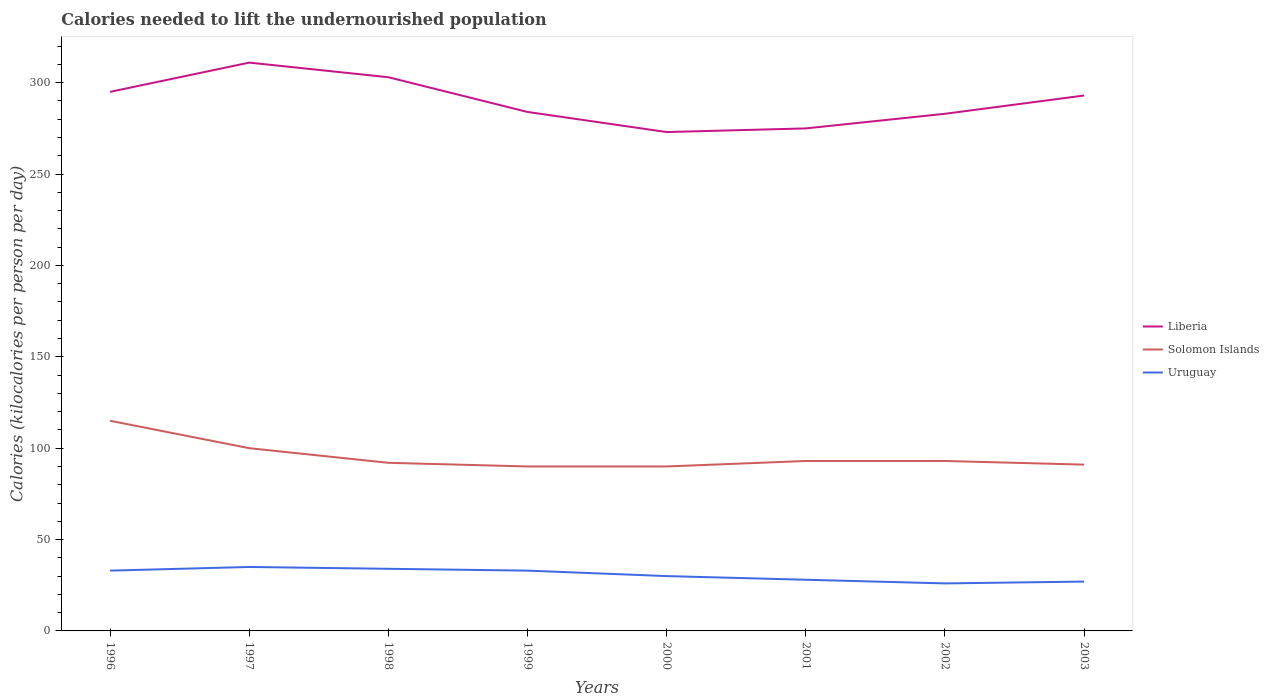How many different coloured lines are there?
Provide a succinct answer. 3. Across all years, what is the maximum total calories needed to lift the undernourished population in Uruguay?
Your answer should be compact. 26. What is the total total calories needed to lift the undernourished population in Liberia in the graph?
Your answer should be compact. 28. What is the difference between the highest and the second highest total calories needed to lift the undernourished population in Uruguay?
Offer a very short reply. 9. What is the difference between the highest and the lowest total calories needed to lift the undernourished population in Liberia?
Provide a short and direct response. 4. Is the total calories needed to lift the undernourished population in Uruguay strictly greater than the total calories needed to lift the undernourished population in Solomon Islands over the years?
Provide a succinct answer. Yes. How many years are there in the graph?
Offer a terse response. 8. What is the difference between two consecutive major ticks on the Y-axis?
Offer a terse response. 50. Are the values on the major ticks of Y-axis written in scientific E-notation?
Your response must be concise. No. Does the graph contain any zero values?
Provide a short and direct response. No. Does the graph contain grids?
Keep it short and to the point. No. Where does the legend appear in the graph?
Make the answer very short. Center right. How are the legend labels stacked?
Give a very brief answer. Vertical. What is the title of the graph?
Provide a short and direct response. Calories needed to lift the undernourished population. What is the label or title of the Y-axis?
Keep it short and to the point. Calories (kilocalories per person per day). What is the Calories (kilocalories per person per day) of Liberia in 1996?
Make the answer very short. 295. What is the Calories (kilocalories per person per day) in Solomon Islands in 1996?
Offer a terse response. 115. What is the Calories (kilocalories per person per day) in Uruguay in 1996?
Your answer should be very brief. 33. What is the Calories (kilocalories per person per day) of Liberia in 1997?
Offer a terse response. 311. What is the Calories (kilocalories per person per day) of Liberia in 1998?
Make the answer very short. 303. What is the Calories (kilocalories per person per day) of Solomon Islands in 1998?
Give a very brief answer. 92. What is the Calories (kilocalories per person per day) in Liberia in 1999?
Give a very brief answer. 284. What is the Calories (kilocalories per person per day) in Solomon Islands in 1999?
Keep it short and to the point. 90. What is the Calories (kilocalories per person per day) of Liberia in 2000?
Offer a terse response. 273. What is the Calories (kilocalories per person per day) in Solomon Islands in 2000?
Provide a short and direct response. 90. What is the Calories (kilocalories per person per day) in Uruguay in 2000?
Give a very brief answer. 30. What is the Calories (kilocalories per person per day) in Liberia in 2001?
Your response must be concise. 275. What is the Calories (kilocalories per person per day) of Solomon Islands in 2001?
Your answer should be very brief. 93. What is the Calories (kilocalories per person per day) of Liberia in 2002?
Offer a terse response. 283. What is the Calories (kilocalories per person per day) of Solomon Islands in 2002?
Offer a very short reply. 93. What is the Calories (kilocalories per person per day) of Liberia in 2003?
Your answer should be very brief. 293. What is the Calories (kilocalories per person per day) of Solomon Islands in 2003?
Provide a short and direct response. 91. What is the Calories (kilocalories per person per day) in Uruguay in 2003?
Provide a succinct answer. 27. Across all years, what is the maximum Calories (kilocalories per person per day) of Liberia?
Make the answer very short. 311. Across all years, what is the maximum Calories (kilocalories per person per day) of Solomon Islands?
Make the answer very short. 115. Across all years, what is the maximum Calories (kilocalories per person per day) of Uruguay?
Ensure brevity in your answer.  35. Across all years, what is the minimum Calories (kilocalories per person per day) of Liberia?
Your response must be concise. 273. Across all years, what is the minimum Calories (kilocalories per person per day) in Solomon Islands?
Provide a short and direct response. 90. Across all years, what is the minimum Calories (kilocalories per person per day) in Uruguay?
Give a very brief answer. 26. What is the total Calories (kilocalories per person per day) in Liberia in the graph?
Make the answer very short. 2317. What is the total Calories (kilocalories per person per day) of Solomon Islands in the graph?
Offer a very short reply. 764. What is the total Calories (kilocalories per person per day) in Uruguay in the graph?
Provide a succinct answer. 246. What is the difference between the Calories (kilocalories per person per day) of Liberia in 1996 and that in 1997?
Your answer should be very brief. -16. What is the difference between the Calories (kilocalories per person per day) of Solomon Islands in 1996 and that in 1997?
Your answer should be compact. 15. What is the difference between the Calories (kilocalories per person per day) of Solomon Islands in 1996 and that in 1999?
Give a very brief answer. 25. What is the difference between the Calories (kilocalories per person per day) of Uruguay in 1996 and that in 1999?
Your answer should be compact. 0. What is the difference between the Calories (kilocalories per person per day) in Uruguay in 1996 and that in 2000?
Keep it short and to the point. 3. What is the difference between the Calories (kilocalories per person per day) in Liberia in 1996 and that in 2002?
Your answer should be very brief. 12. What is the difference between the Calories (kilocalories per person per day) in Uruguay in 1996 and that in 2002?
Your answer should be very brief. 7. What is the difference between the Calories (kilocalories per person per day) of Liberia in 1996 and that in 2003?
Provide a succinct answer. 2. What is the difference between the Calories (kilocalories per person per day) of Solomon Islands in 1996 and that in 2003?
Make the answer very short. 24. What is the difference between the Calories (kilocalories per person per day) of Uruguay in 1996 and that in 2003?
Give a very brief answer. 6. What is the difference between the Calories (kilocalories per person per day) in Uruguay in 1997 and that in 1998?
Provide a succinct answer. 1. What is the difference between the Calories (kilocalories per person per day) of Liberia in 1997 and that in 1999?
Offer a very short reply. 27. What is the difference between the Calories (kilocalories per person per day) in Uruguay in 1997 and that in 2000?
Give a very brief answer. 5. What is the difference between the Calories (kilocalories per person per day) of Solomon Islands in 1997 and that in 2002?
Give a very brief answer. 7. What is the difference between the Calories (kilocalories per person per day) in Uruguay in 1997 and that in 2002?
Offer a terse response. 9. What is the difference between the Calories (kilocalories per person per day) of Solomon Islands in 1998 and that in 1999?
Offer a terse response. 2. What is the difference between the Calories (kilocalories per person per day) in Solomon Islands in 1998 and that in 2000?
Make the answer very short. 2. What is the difference between the Calories (kilocalories per person per day) of Uruguay in 1998 and that in 2000?
Offer a terse response. 4. What is the difference between the Calories (kilocalories per person per day) of Solomon Islands in 1998 and that in 2001?
Your answer should be very brief. -1. What is the difference between the Calories (kilocalories per person per day) in Uruguay in 1998 and that in 2001?
Your answer should be compact. 6. What is the difference between the Calories (kilocalories per person per day) in Liberia in 1998 and that in 2002?
Offer a terse response. 20. What is the difference between the Calories (kilocalories per person per day) in Solomon Islands in 1998 and that in 2002?
Keep it short and to the point. -1. What is the difference between the Calories (kilocalories per person per day) of Uruguay in 1998 and that in 2002?
Provide a short and direct response. 8. What is the difference between the Calories (kilocalories per person per day) in Liberia in 1998 and that in 2003?
Make the answer very short. 10. What is the difference between the Calories (kilocalories per person per day) of Liberia in 1999 and that in 2000?
Your response must be concise. 11. What is the difference between the Calories (kilocalories per person per day) of Solomon Islands in 1999 and that in 2000?
Your answer should be very brief. 0. What is the difference between the Calories (kilocalories per person per day) in Solomon Islands in 1999 and that in 2001?
Make the answer very short. -3. What is the difference between the Calories (kilocalories per person per day) of Liberia in 1999 and that in 2002?
Provide a succinct answer. 1. What is the difference between the Calories (kilocalories per person per day) in Solomon Islands in 1999 and that in 2002?
Provide a short and direct response. -3. What is the difference between the Calories (kilocalories per person per day) of Uruguay in 1999 and that in 2002?
Give a very brief answer. 7. What is the difference between the Calories (kilocalories per person per day) of Liberia in 1999 and that in 2003?
Your response must be concise. -9. What is the difference between the Calories (kilocalories per person per day) in Solomon Islands in 1999 and that in 2003?
Your answer should be very brief. -1. What is the difference between the Calories (kilocalories per person per day) of Uruguay in 2000 and that in 2001?
Make the answer very short. 2. What is the difference between the Calories (kilocalories per person per day) in Solomon Islands in 2000 and that in 2002?
Provide a short and direct response. -3. What is the difference between the Calories (kilocalories per person per day) of Uruguay in 2000 and that in 2002?
Provide a succinct answer. 4. What is the difference between the Calories (kilocalories per person per day) of Liberia in 2000 and that in 2003?
Make the answer very short. -20. What is the difference between the Calories (kilocalories per person per day) in Solomon Islands in 2000 and that in 2003?
Ensure brevity in your answer.  -1. What is the difference between the Calories (kilocalories per person per day) of Solomon Islands in 2001 and that in 2002?
Keep it short and to the point. 0. What is the difference between the Calories (kilocalories per person per day) of Uruguay in 2001 and that in 2002?
Give a very brief answer. 2. What is the difference between the Calories (kilocalories per person per day) in Solomon Islands in 2001 and that in 2003?
Keep it short and to the point. 2. What is the difference between the Calories (kilocalories per person per day) in Liberia in 2002 and that in 2003?
Your answer should be very brief. -10. What is the difference between the Calories (kilocalories per person per day) in Uruguay in 2002 and that in 2003?
Provide a short and direct response. -1. What is the difference between the Calories (kilocalories per person per day) of Liberia in 1996 and the Calories (kilocalories per person per day) of Solomon Islands in 1997?
Your response must be concise. 195. What is the difference between the Calories (kilocalories per person per day) of Liberia in 1996 and the Calories (kilocalories per person per day) of Uruguay in 1997?
Your answer should be compact. 260. What is the difference between the Calories (kilocalories per person per day) in Liberia in 1996 and the Calories (kilocalories per person per day) in Solomon Islands in 1998?
Keep it short and to the point. 203. What is the difference between the Calories (kilocalories per person per day) of Liberia in 1996 and the Calories (kilocalories per person per day) of Uruguay in 1998?
Your answer should be very brief. 261. What is the difference between the Calories (kilocalories per person per day) of Liberia in 1996 and the Calories (kilocalories per person per day) of Solomon Islands in 1999?
Provide a short and direct response. 205. What is the difference between the Calories (kilocalories per person per day) of Liberia in 1996 and the Calories (kilocalories per person per day) of Uruguay in 1999?
Your response must be concise. 262. What is the difference between the Calories (kilocalories per person per day) in Solomon Islands in 1996 and the Calories (kilocalories per person per day) in Uruguay in 1999?
Your response must be concise. 82. What is the difference between the Calories (kilocalories per person per day) in Liberia in 1996 and the Calories (kilocalories per person per day) in Solomon Islands in 2000?
Offer a very short reply. 205. What is the difference between the Calories (kilocalories per person per day) in Liberia in 1996 and the Calories (kilocalories per person per day) in Uruguay in 2000?
Make the answer very short. 265. What is the difference between the Calories (kilocalories per person per day) in Liberia in 1996 and the Calories (kilocalories per person per day) in Solomon Islands in 2001?
Provide a succinct answer. 202. What is the difference between the Calories (kilocalories per person per day) of Liberia in 1996 and the Calories (kilocalories per person per day) of Uruguay in 2001?
Offer a very short reply. 267. What is the difference between the Calories (kilocalories per person per day) in Solomon Islands in 1996 and the Calories (kilocalories per person per day) in Uruguay in 2001?
Your response must be concise. 87. What is the difference between the Calories (kilocalories per person per day) in Liberia in 1996 and the Calories (kilocalories per person per day) in Solomon Islands in 2002?
Offer a terse response. 202. What is the difference between the Calories (kilocalories per person per day) in Liberia in 1996 and the Calories (kilocalories per person per day) in Uruguay in 2002?
Your response must be concise. 269. What is the difference between the Calories (kilocalories per person per day) of Solomon Islands in 1996 and the Calories (kilocalories per person per day) of Uruguay in 2002?
Provide a succinct answer. 89. What is the difference between the Calories (kilocalories per person per day) of Liberia in 1996 and the Calories (kilocalories per person per day) of Solomon Islands in 2003?
Provide a succinct answer. 204. What is the difference between the Calories (kilocalories per person per day) of Liberia in 1996 and the Calories (kilocalories per person per day) of Uruguay in 2003?
Your response must be concise. 268. What is the difference between the Calories (kilocalories per person per day) in Liberia in 1997 and the Calories (kilocalories per person per day) in Solomon Islands in 1998?
Keep it short and to the point. 219. What is the difference between the Calories (kilocalories per person per day) of Liberia in 1997 and the Calories (kilocalories per person per day) of Uruguay in 1998?
Your response must be concise. 277. What is the difference between the Calories (kilocalories per person per day) in Solomon Islands in 1997 and the Calories (kilocalories per person per day) in Uruguay in 1998?
Ensure brevity in your answer.  66. What is the difference between the Calories (kilocalories per person per day) in Liberia in 1997 and the Calories (kilocalories per person per day) in Solomon Islands in 1999?
Offer a terse response. 221. What is the difference between the Calories (kilocalories per person per day) of Liberia in 1997 and the Calories (kilocalories per person per day) of Uruguay in 1999?
Offer a very short reply. 278. What is the difference between the Calories (kilocalories per person per day) of Liberia in 1997 and the Calories (kilocalories per person per day) of Solomon Islands in 2000?
Make the answer very short. 221. What is the difference between the Calories (kilocalories per person per day) of Liberia in 1997 and the Calories (kilocalories per person per day) of Uruguay in 2000?
Give a very brief answer. 281. What is the difference between the Calories (kilocalories per person per day) in Solomon Islands in 1997 and the Calories (kilocalories per person per day) in Uruguay in 2000?
Give a very brief answer. 70. What is the difference between the Calories (kilocalories per person per day) of Liberia in 1997 and the Calories (kilocalories per person per day) of Solomon Islands in 2001?
Your response must be concise. 218. What is the difference between the Calories (kilocalories per person per day) in Liberia in 1997 and the Calories (kilocalories per person per day) in Uruguay in 2001?
Your answer should be very brief. 283. What is the difference between the Calories (kilocalories per person per day) in Liberia in 1997 and the Calories (kilocalories per person per day) in Solomon Islands in 2002?
Offer a terse response. 218. What is the difference between the Calories (kilocalories per person per day) in Liberia in 1997 and the Calories (kilocalories per person per day) in Uruguay in 2002?
Provide a short and direct response. 285. What is the difference between the Calories (kilocalories per person per day) in Solomon Islands in 1997 and the Calories (kilocalories per person per day) in Uruguay in 2002?
Your answer should be compact. 74. What is the difference between the Calories (kilocalories per person per day) in Liberia in 1997 and the Calories (kilocalories per person per day) in Solomon Islands in 2003?
Offer a terse response. 220. What is the difference between the Calories (kilocalories per person per day) in Liberia in 1997 and the Calories (kilocalories per person per day) in Uruguay in 2003?
Make the answer very short. 284. What is the difference between the Calories (kilocalories per person per day) in Liberia in 1998 and the Calories (kilocalories per person per day) in Solomon Islands in 1999?
Offer a terse response. 213. What is the difference between the Calories (kilocalories per person per day) of Liberia in 1998 and the Calories (kilocalories per person per day) of Uruguay in 1999?
Your answer should be very brief. 270. What is the difference between the Calories (kilocalories per person per day) in Solomon Islands in 1998 and the Calories (kilocalories per person per day) in Uruguay in 1999?
Your response must be concise. 59. What is the difference between the Calories (kilocalories per person per day) of Liberia in 1998 and the Calories (kilocalories per person per day) of Solomon Islands in 2000?
Your response must be concise. 213. What is the difference between the Calories (kilocalories per person per day) of Liberia in 1998 and the Calories (kilocalories per person per day) of Uruguay in 2000?
Keep it short and to the point. 273. What is the difference between the Calories (kilocalories per person per day) of Solomon Islands in 1998 and the Calories (kilocalories per person per day) of Uruguay in 2000?
Provide a succinct answer. 62. What is the difference between the Calories (kilocalories per person per day) in Liberia in 1998 and the Calories (kilocalories per person per day) in Solomon Islands in 2001?
Your answer should be compact. 210. What is the difference between the Calories (kilocalories per person per day) in Liberia in 1998 and the Calories (kilocalories per person per day) in Uruguay in 2001?
Offer a very short reply. 275. What is the difference between the Calories (kilocalories per person per day) in Solomon Islands in 1998 and the Calories (kilocalories per person per day) in Uruguay in 2001?
Give a very brief answer. 64. What is the difference between the Calories (kilocalories per person per day) in Liberia in 1998 and the Calories (kilocalories per person per day) in Solomon Islands in 2002?
Your answer should be very brief. 210. What is the difference between the Calories (kilocalories per person per day) in Liberia in 1998 and the Calories (kilocalories per person per day) in Uruguay in 2002?
Your response must be concise. 277. What is the difference between the Calories (kilocalories per person per day) in Liberia in 1998 and the Calories (kilocalories per person per day) in Solomon Islands in 2003?
Offer a terse response. 212. What is the difference between the Calories (kilocalories per person per day) of Liberia in 1998 and the Calories (kilocalories per person per day) of Uruguay in 2003?
Ensure brevity in your answer.  276. What is the difference between the Calories (kilocalories per person per day) in Liberia in 1999 and the Calories (kilocalories per person per day) in Solomon Islands in 2000?
Offer a terse response. 194. What is the difference between the Calories (kilocalories per person per day) of Liberia in 1999 and the Calories (kilocalories per person per day) of Uruguay in 2000?
Ensure brevity in your answer.  254. What is the difference between the Calories (kilocalories per person per day) of Liberia in 1999 and the Calories (kilocalories per person per day) of Solomon Islands in 2001?
Provide a short and direct response. 191. What is the difference between the Calories (kilocalories per person per day) of Liberia in 1999 and the Calories (kilocalories per person per day) of Uruguay in 2001?
Your answer should be compact. 256. What is the difference between the Calories (kilocalories per person per day) in Solomon Islands in 1999 and the Calories (kilocalories per person per day) in Uruguay in 2001?
Offer a very short reply. 62. What is the difference between the Calories (kilocalories per person per day) of Liberia in 1999 and the Calories (kilocalories per person per day) of Solomon Islands in 2002?
Give a very brief answer. 191. What is the difference between the Calories (kilocalories per person per day) of Liberia in 1999 and the Calories (kilocalories per person per day) of Uruguay in 2002?
Keep it short and to the point. 258. What is the difference between the Calories (kilocalories per person per day) in Liberia in 1999 and the Calories (kilocalories per person per day) in Solomon Islands in 2003?
Provide a short and direct response. 193. What is the difference between the Calories (kilocalories per person per day) of Liberia in 1999 and the Calories (kilocalories per person per day) of Uruguay in 2003?
Offer a terse response. 257. What is the difference between the Calories (kilocalories per person per day) in Solomon Islands in 1999 and the Calories (kilocalories per person per day) in Uruguay in 2003?
Offer a terse response. 63. What is the difference between the Calories (kilocalories per person per day) in Liberia in 2000 and the Calories (kilocalories per person per day) in Solomon Islands in 2001?
Your response must be concise. 180. What is the difference between the Calories (kilocalories per person per day) in Liberia in 2000 and the Calories (kilocalories per person per day) in Uruguay in 2001?
Keep it short and to the point. 245. What is the difference between the Calories (kilocalories per person per day) of Liberia in 2000 and the Calories (kilocalories per person per day) of Solomon Islands in 2002?
Your answer should be very brief. 180. What is the difference between the Calories (kilocalories per person per day) of Liberia in 2000 and the Calories (kilocalories per person per day) of Uruguay in 2002?
Keep it short and to the point. 247. What is the difference between the Calories (kilocalories per person per day) in Solomon Islands in 2000 and the Calories (kilocalories per person per day) in Uruguay in 2002?
Your response must be concise. 64. What is the difference between the Calories (kilocalories per person per day) in Liberia in 2000 and the Calories (kilocalories per person per day) in Solomon Islands in 2003?
Provide a succinct answer. 182. What is the difference between the Calories (kilocalories per person per day) of Liberia in 2000 and the Calories (kilocalories per person per day) of Uruguay in 2003?
Provide a short and direct response. 246. What is the difference between the Calories (kilocalories per person per day) of Solomon Islands in 2000 and the Calories (kilocalories per person per day) of Uruguay in 2003?
Provide a short and direct response. 63. What is the difference between the Calories (kilocalories per person per day) in Liberia in 2001 and the Calories (kilocalories per person per day) in Solomon Islands in 2002?
Give a very brief answer. 182. What is the difference between the Calories (kilocalories per person per day) in Liberia in 2001 and the Calories (kilocalories per person per day) in Uruguay in 2002?
Your answer should be compact. 249. What is the difference between the Calories (kilocalories per person per day) of Solomon Islands in 2001 and the Calories (kilocalories per person per day) of Uruguay in 2002?
Your response must be concise. 67. What is the difference between the Calories (kilocalories per person per day) in Liberia in 2001 and the Calories (kilocalories per person per day) in Solomon Islands in 2003?
Ensure brevity in your answer.  184. What is the difference between the Calories (kilocalories per person per day) in Liberia in 2001 and the Calories (kilocalories per person per day) in Uruguay in 2003?
Provide a short and direct response. 248. What is the difference between the Calories (kilocalories per person per day) of Solomon Islands in 2001 and the Calories (kilocalories per person per day) of Uruguay in 2003?
Your answer should be compact. 66. What is the difference between the Calories (kilocalories per person per day) of Liberia in 2002 and the Calories (kilocalories per person per day) of Solomon Islands in 2003?
Provide a succinct answer. 192. What is the difference between the Calories (kilocalories per person per day) of Liberia in 2002 and the Calories (kilocalories per person per day) of Uruguay in 2003?
Provide a short and direct response. 256. What is the average Calories (kilocalories per person per day) of Liberia per year?
Offer a very short reply. 289.62. What is the average Calories (kilocalories per person per day) of Solomon Islands per year?
Your response must be concise. 95.5. What is the average Calories (kilocalories per person per day) in Uruguay per year?
Your response must be concise. 30.75. In the year 1996, what is the difference between the Calories (kilocalories per person per day) in Liberia and Calories (kilocalories per person per day) in Solomon Islands?
Keep it short and to the point. 180. In the year 1996, what is the difference between the Calories (kilocalories per person per day) in Liberia and Calories (kilocalories per person per day) in Uruguay?
Give a very brief answer. 262. In the year 1996, what is the difference between the Calories (kilocalories per person per day) in Solomon Islands and Calories (kilocalories per person per day) in Uruguay?
Keep it short and to the point. 82. In the year 1997, what is the difference between the Calories (kilocalories per person per day) in Liberia and Calories (kilocalories per person per day) in Solomon Islands?
Offer a terse response. 211. In the year 1997, what is the difference between the Calories (kilocalories per person per day) of Liberia and Calories (kilocalories per person per day) of Uruguay?
Your answer should be compact. 276. In the year 1997, what is the difference between the Calories (kilocalories per person per day) in Solomon Islands and Calories (kilocalories per person per day) in Uruguay?
Offer a very short reply. 65. In the year 1998, what is the difference between the Calories (kilocalories per person per day) of Liberia and Calories (kilocalories per person per day) of Solomon Islands?
Make the answer very short. 211. In the year 1998, what is the difference between the Calories (kilocalories per person per day) of Liberia and Calories (kilocalories per person per day) of Uruguay?
Your answer should be very brief. 269. In the year 1998, what is the difference between the Calories (kilocalories per person per day) in Solomon Islands and Calories (kilocalories per person per day) in Uruguay?
Provide a succinct answer. 58. In the year 1999, what is the difference between the Calories (kilocalories per person per day) of Liberia and Calories (kilocalories per person per day) of Solomon Islands?
Provide a short and direct response. 194. In the year 1999, what is the difference between the Calories (kilocalories per person per day) in Liberia and Calories (kilocalories per person per day) in Uruguay?
Ensure brevity in your answer.  251. In the year 1999, what is the difference between the Calories (kilocalories per person per day) of Solomon Islands and Calories (kilocalories per person per day) of Uruguay?
Give a very brief answer. 57. In the year 2000, what is the difference between the Calories (kilocalories per person per day) in Liberia and Calories (kilocalories per person per day) in Solomon Islands?
Offer a terse response. 183. In the year 2000, what is the difference between the Calories (kilocalories per person per day) in Liberia and Calories (kilocalories per person per day) in Uruguay?
Make the answer very short. 243. In the year 2000, what is the difference between the Calories (kilocalories per person per day) in Solomon Islands and Calories (kilocalories per person per day) in Uruguay?
Offer a very short reply. 60. In the year 2001, what is the difference between the Calories (kilocalories per person per day) in Liberia and Calories (kilocalories per person per day) in Solomon Islands?
Your answer should be compact. 182. In the year 2001, what is the difference between the Calories (kilocalories per person per day) in Liberia and Calories (kilocalories per person per day) in Uruguay?
Offer a very short reply. 247. In the year 2002, what is the difference between the Calories (kilocalories per person per day) in Liberia and Calories (kilocalories per person per day) in Solomon Islands?
Offer a terse response. 190. In the year 2002, what is the difference between the Calories (kilocalories per person per day) in Liberia and Calories (kilocalories per person per day) in Uruguay?
Keep it short and to the point. 257. In the year 2003, what is the difference between the Calories (kilocalories per person per day) in Liberia and Calories (kilocalories per person per day) in Solomon Islands?
Offer a terse response. 202. In the year 2003, what is the difference between the Calories (kilocalories per person per day) of Liberia and Calories (kilocalories per person per day) of Uruguay?
Provide a short and direct response. 266. In the year 2003, what is the difference between the Calories (kilocalories per person per day) in Solomon Islands and Calories (kilocalories per person per day) in Uruguay?
Your answer should be very brief. 64. What is the ratio of the Calories (kilocalories per person per day) in Liberia in 1996 to that in 1997?
Give a very brief answer. 0.95. What is the ratio of the Calories (kilocalories per person per day) in Solomon Islands in 1996 to that in 1997?
Give a very brief answer. 1.15. What is the ratio of the Calories (kilocalories per person per day) of Uruguay in 1996 to that in 1997?
Provide a short and direct response. 0.94. What is the ratio of the Calories (kilocalories per person per day) of Liberia in 1996 to that in 1998?
Make the answer very short. 0.97. What is the ratio of the Calories (kilocalories per person per day) of Uruguay in 1996 to that in 1998?
Offer a very short reply. 0.97. What is the ratio of the Calories (kilocalories per person per day) of Liberia in 1996 to that in 1999?
Keep it short and to the point. 1.04. What is the ratio of the Calories (kilocalories per person per day) of Solomon Islands in 1996 to that in 1999?
Offer a very short reply. 1.28. What is the ratio of the Calories (kilocalories per person per day) in Liberia in 1996 to that in 2000?
Keep it short and to the point. 1.08. What is the ratio of the Calories (kilocalories per person per day) of Solomon Islands in 1996 to that in 2000?
Your response must be concise. 1.28. What is the ratio of the Calories (kilocalories per person per day) of Liberia in 1996 to that in 2001?
Give a very brief answer. 1.07. What is the ratio of the Calories (kilocalories per person per day) in Solomon Islands in 1996 to that in 2001?
Ensure brevity in your answer.  1.24. What is the ratio of the Calories (kilocalories per person per day) in Uruguay in 1996 to that in 2001?
Provide a succinct answer. 1.18. What is the ratio of the Calories (kilocalories per person per day) of Liberia in 1996 to that in 2002?
Ensure brevity in your answer.  1.04. What is the ratio of the Calories (kilocalories per person per day) in Solomon Islands in 1996 to that in 2002?
Offer a terse response. 1.24. What is the ratio of the Calories (kilocalories per person per day) of Uruguay in 1996 to that in 2002?
Provide a succinct answer. 1.27. What is the ratio of the Calories (kilocalories per person per day) in Liberia in 1996 to that in 2003?
Provide a succinct answer. 1.01. What is the ratio of the Calories (kilocalories per person per day) in Solomon Islands in 1996 to that in 2003?
Offer a terse response. 1.26. What is the ratio of the Calories (kilocalories per person per day) of Uruguay in 1996 to that in 2003?
Keep it short and to the point. 1.22. What is the ratio of the Calories (kilocalories per person per day) of Liberia in 1997 to that in 1998?
Provide a short and direct response. 1.03. What is the ratio of the Calories (kilocalories per person per day) of Solomon Islands in 1997 to that in 1998?
Ensure brevity in your answer.  1.09. What is the ratio of the Calories (kilocalories per person per day) of Uruguay in 1997 to that in 1998?
Your answer should be compact. 1.03. What is the ratio of the Calories (kilocalories per person per day) in Liberia in 1997 to that in 1999?
Provide a succinct answer. 1.1. What is the ratio of the Calories (kilocalories per person per day) in Uruguay in 1997 to that in 1999?
Provide a short and direct response. 1.06. What is the ratio of the Calories (kilocalories per person per day) of Liberia in 1997 to that in 2000?
Offer a terse response. 1.14. What is the ratio of the Calories (kilocalories per person per day) in Solomon Islands in 1997 to that in 2000?
Provide a succinct answer. 1.11. What is the ratio of the Calories (kilocalories per person per day) in Liberia in 1997 to that in 2001?
Your answer should be compact. 1.13. What is the ratio of the Calories (kilocalories per person per day) of Solomon Islands in 1997 to that in 2001?
Give a very brief answer. 1.08. What is the ratio of the Calories (kilocalories per person per day) in Uruguay in 1997 to that in 2001?
Make the answer very short. 1.25. What is the ratio of the Calories (kilocalories per person per day) in Liberia in 1997 to that in 2002?
Make the answer very short. 1.1. What is the ratio of the Calories (kilocalories per person per day) of Solomon Islands in 1997 to that in 2002?
Keep it short and to the point. 1.08. What is the ratio of the Calories (kilocalories per person per day) of Uruguay in 1997 to that in 2002?
Your answer should be very brief. 1.35. What is the ratio of the Calories (kilocalories per person per day) of Liberia in 1997 to that in 2003?
Provide a short and direct response. 1.06. What is the ratio of the Calories (kilocalories per person per day) in Solomon Islands in 1997 to that in 2003?
Your answer should be compact. 1.1. What is the ratio of the Calories (kilocalories per person per day) of Uruguay in 1997 to that in 2003?
Offer a very short reply. 1.3. What is the ratio of the Calories (kilocalories per person per day) in Liberia in 1998 to that in 1999?
Offer a terse response. 1.07. What is the ratio of the Calories (kilocalories per person per day) in Solomon Islands in 1998 to that in 1999?
Provide a short and direct response. 1.02. What is the ratio of the Calories (kilocalories per person per day) of Uruguay in 1998 to that in 1999?
Your answer should be compact. 1.03. What is the ratio of the Calories (kilocalories per person per day) of Liberia in 1998 to that in 2000?
Give a very brief answer. 1.11. What is the ratio of the Calories (kilocalories per person per day) of Solomon Islands in 1998 to that in 2000?
Give a very brief answer. 1.02. What is the ratio of the Calories (kilocalories per person per day) of Uruguay in 1998 to that in 2000?
Ensure brevity in your answer.  1.13. What is the ratio of the Calories (kilocalories per person per day) of Liberia in 1998 to that in 2001?
Your answer should be compact. 1.1. What is the ratio of the Calories (kilocalories per person per day) of Solomon Islands in 1998 to that in 2001?
Make the answer very short. 0.99. What is the ratio of the Calories (kilocalories per person per day) of Uruguay in 1998 to that in 2001?
Make the answer very short. 1.21. What is the ratio of the Calories (kilocalories per person per day) in Liberia in 1998 to that in 2002?
Give a very brief answer. 1.07. What is the ratio of the Calories (kilocalories per person per day) of Uruguay in 1998 to that in 2002?
Your answer should be very brief. 1.31. What is the ratio of the Calories (kilocalories per person per day) of Liberia in 1998 to that in 2003?
Make the answer very short. 1.03. What is the ratio of the Calories (kilocalories per person per day) in Uruguay in 1998 to that in 2003?
Your answer should be very brief. 1.26. What is the ratio of the Calories (kilocalories per person per day) of Liberia in 1999 to that in 2000?
Ensure brevity in your answer.  1.04. What is the ratio of the Calories (kilocalories per person per day) in Solomon Islands in 1999 to that in 2000?
Make the answer very short. 1. What is the ratio of the Calories (kilocalories per person per day) in Uruguay in 1999 to that in 2000?
Provide a short and direct response. 1.1. What is the ratio of the Calories (kilocalories per person per day) of Liberia in 1999 to that in 2001?
Make the answer very short. 1.03. What is the ratio of the Calories (kilocalories per person per day) in Uruguay in 1999 to that in 2001?
Give a very brief answer. 1.18. What is the ratio of the Calories (kilocalories per person per day) in Liberia in 1999 to that in 2002?
Keep it short and to the point. 1. What is the ratio of the Calories (kilocalories per person per day) in Solomon Islands in 1999 to that in 2002?
Your answer should be very brief. 0.97. What is the ratio of the Calories (kilocalories per person per day) of Uruguay in 1999 to that in 2002?
Your response must be concise. 1.27. What is the ratio of the Calories (kilocalories per person per day) in Liberia in 1999 to that in 2003?
Your answer should be compact. 0.97. What is the ratio of the Calories (kilocalories per person per day) of Solomon Islands in 1999 to that in 2003?
Provide a short and direct response. 0.99. What is the ratio of the Calories (kilocalories per person per day) in Uruguay in 1999 to that in 2003?
Your answer should be compact. 1.22. What is the ratio of the Calories (kilocalories per person per day) of Solomon Islands in 2000 to that in 2001?
Your answer should be very brief. 0.97. What is the ratio of the Calories (kilocalories per person per day) of Uruguay in 2000 to that in 2001?
Offer a terse response. 1.07. What is the ratio of the Calories (kilocalories per person per day) of Liberia in 2000 to that in 2002?
Your answer should be very brief. 0.96. What is the ratio of the Calories (kilocalories per person per day) in Uruguay in 2000 to that in 2002?
Offer a very short reply. 1.15. What is the ratio of the Calories (kilocalories per person per day) in Liberia in 2000 to that in 2003?
Offer a terse response. 0.93. What is the ratio of the Calories (kilocalories per person per day) of Uruguay in 2000 to that in 2003?
Ensure brevity in your answer.  1.11. What is the ratio of the Calories (kilocalories per person per day) in Liberia in 2001 to that in 2002?
Your response must be concise. 0.97. What is the ratio of the Calories (kilocalories per person per day) in Solomon Islands in 2001 to that in 2002?
Your response must be concise. 1. What is the ratio of the Calories (kilocalories per person per day) in Uruguay in 2001 to that in 2002?
Offer a terse response. 1.08. What is the ratio of the Calories (kilocalories per person per day) of Liberia in 2001 to that in 2003?
Offer a very short reply. 0.94. What is the ratio of the Calories (kilocalories per person per day) of Solomon Islands in 2001 to that in 2003?
Keep it short and to the point. 1.02. What is the ratio of the Calories (kilocalories per person per day) of Liberia in 2002 to that in 2003?
Make the answer very short. 0.97. What is the ratio of the Calories (kilocalories per person per day) in Uruguay in 2002 to that in 2003?
Provide a short and direct response. 0.96. What is the difference between the highest and the second highest Calories (kilocalories per person per day) in Solomon Islands?
Your response must be concise. 15. What is the difference between the highest and the lowest Calories (kilocalories per person per day) of Solomon Islands?
Make the answer very short. 25. What is the difference between the highest and the lowest Calories (kilocalories per person per day) in Uruguay?
Your answer should be very brief. 9. 